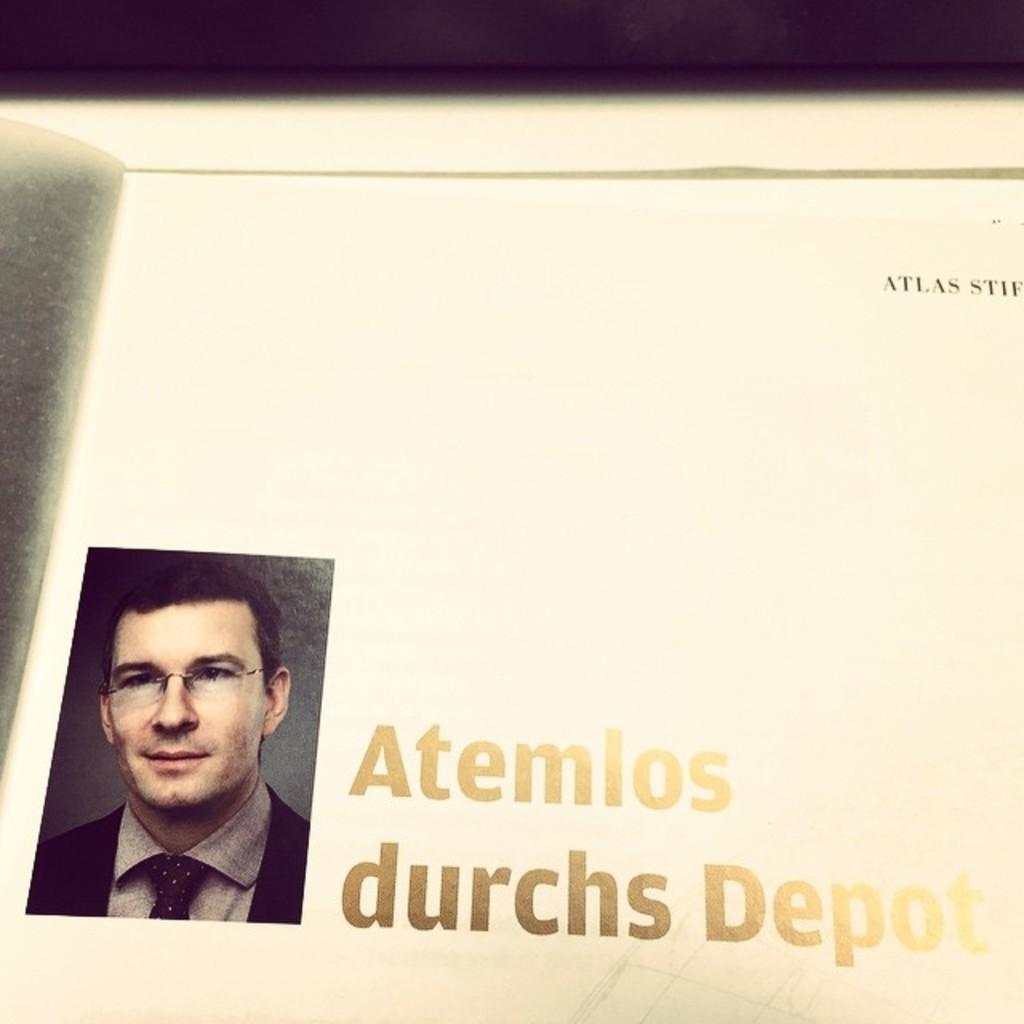Could you give a brief overview of what you see in this image? In the picture there is a page of a book, there is a photograph of a person present, there is some text present. 